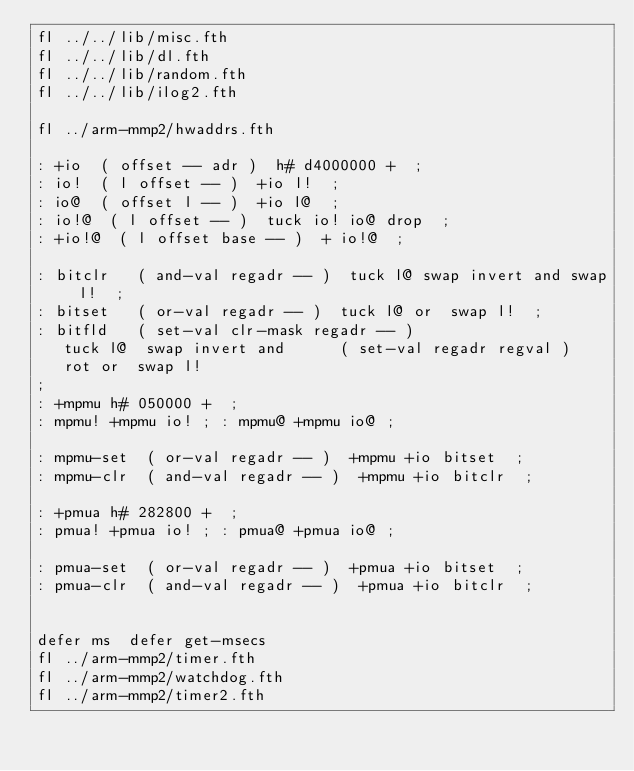<code> <loc_0><loc_0><loc_500><loc_500><_Forth_>fl ../../lib/misc.fth
fl ../../lib/dl.fth
fl ../../lib/random.fth
fl ../../lib/ilog2.fth

fl ../arm-mmp2/hwaddrs.fth

: +io  ( offset -- adr )  h# d4000000 +  ;
: io!  ( l offset -- )  +io l!  ;
: io@  ( offset l -- )  +io l@  ;
: io!@  ( l offset -- )  tuck io! io@ drop  ;
: +io!@  ( l offset base -- )  + io!@  ;

: bitclr   ( and-val regadr -- )  tuck l@ swap invert and swap l!  ;
: bitset   ( or-val regadr -- )  tuck l@ or  swap l!  ;
: bitfld   ( set-val clr-mask regadr -- )
   tuck l@  swap invert and      ( set-val regadr regval )
   rot or  swap l!
;
: +mpmu h# 050000 +  ; 
: mpmu! +mpmu io! ; : mpmu@ +mpmu io@ ;

: mpmu-set  ( or-val regadr -- )  +mpmu +io bitset  ;
: mpmu-clr  ( and-val regadr -- )  +mpmu +io bitclr  ;

: +pmua h# 282800 +  ; 
: pmua! +pmua io! ; : pmua@ +pmua io@ ;

: pmua-set  ( or-val regadr -- )  +pmua +io bitset  ;
: pmua-clr  ( and-val regadr -- )  +pmua +io bitclr  ;


defer ms  defer get-msecs
fl ../arm-mmp2/timer.fth
fl ../arm-mmp2/watchdog.fth
fl ../arm-mmp2/timer2.fth</code> 